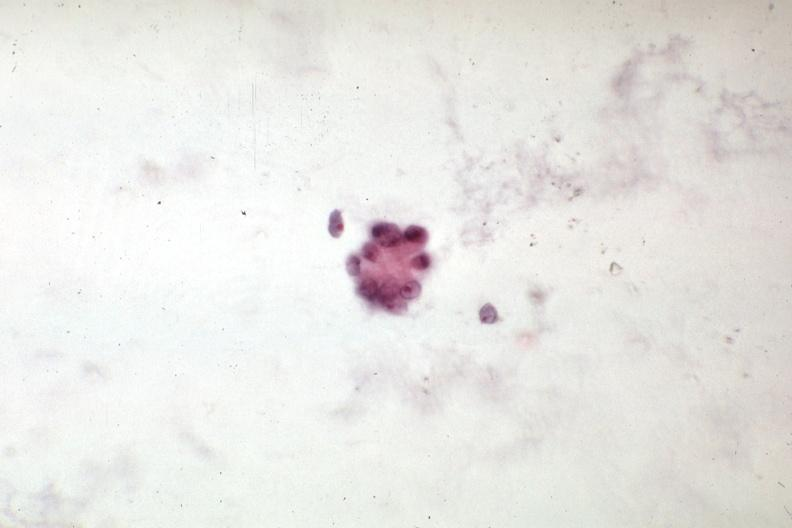what is present?
Answer the question using a single word or phrase. Carcinoma 